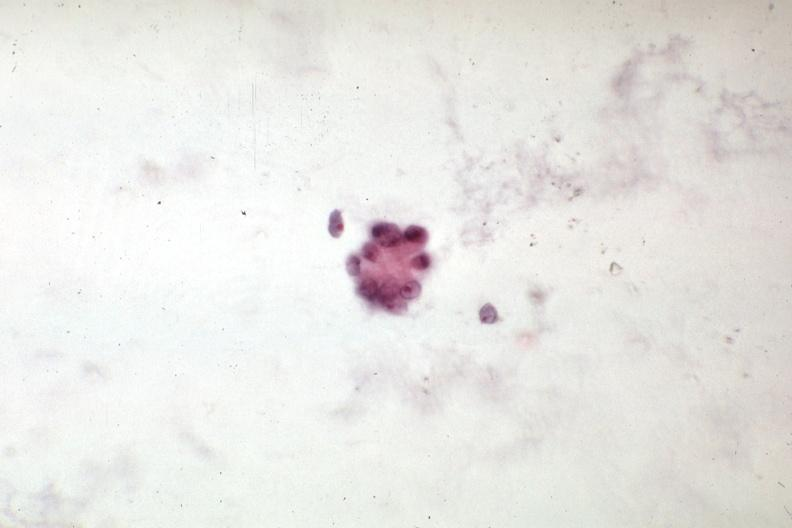what is present?
Answer the question using a single word or phrase. Carcinoma 